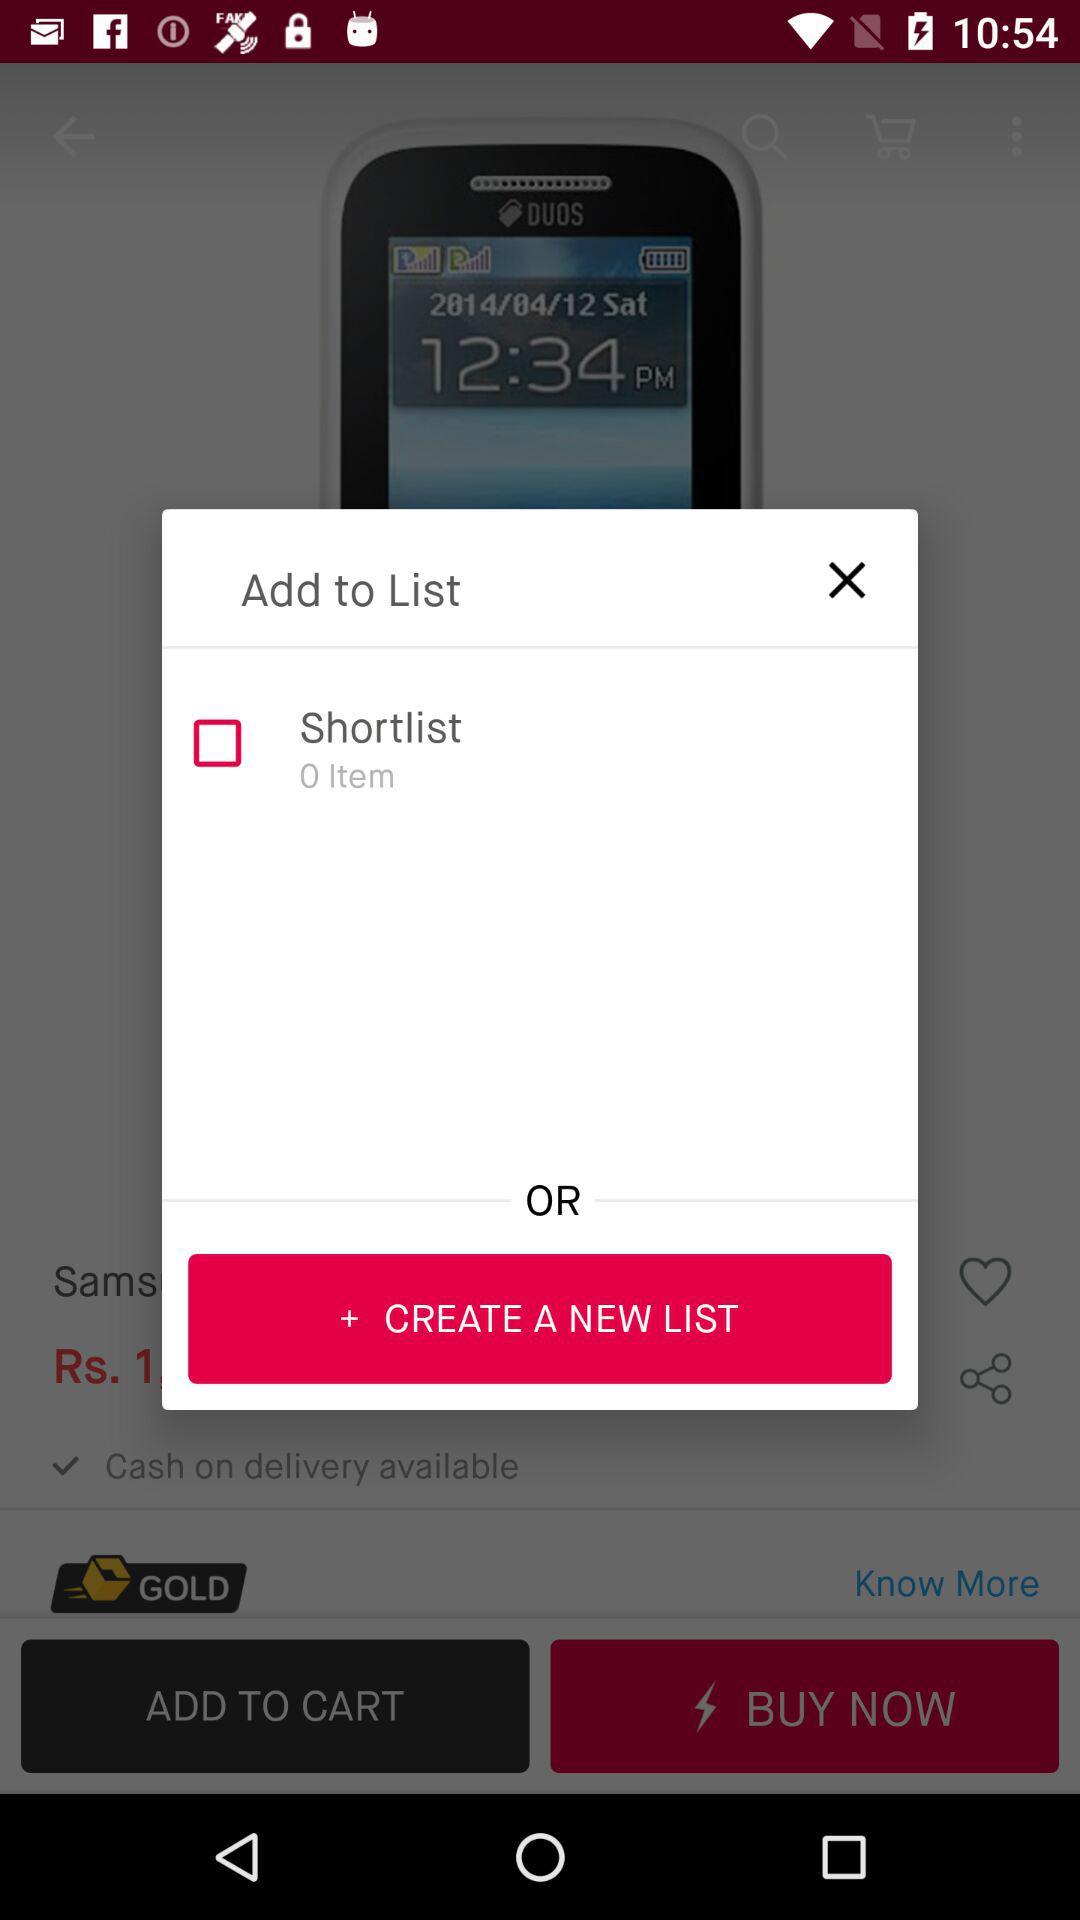How many items are there in the "Shortlist"? There are 0 items. 